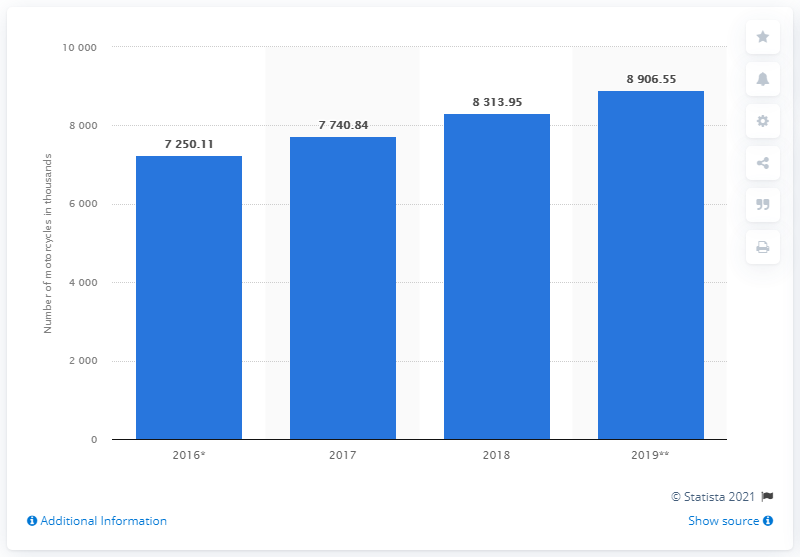Specify some key components in this picture. The sum of 2016 and 2017 is 14990.95. In the year 2019, there was a total of 8906.55. 